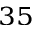<formula> <loc_0><loc_0><loc_500><loc_500>^ { 3 5 }</formula> 